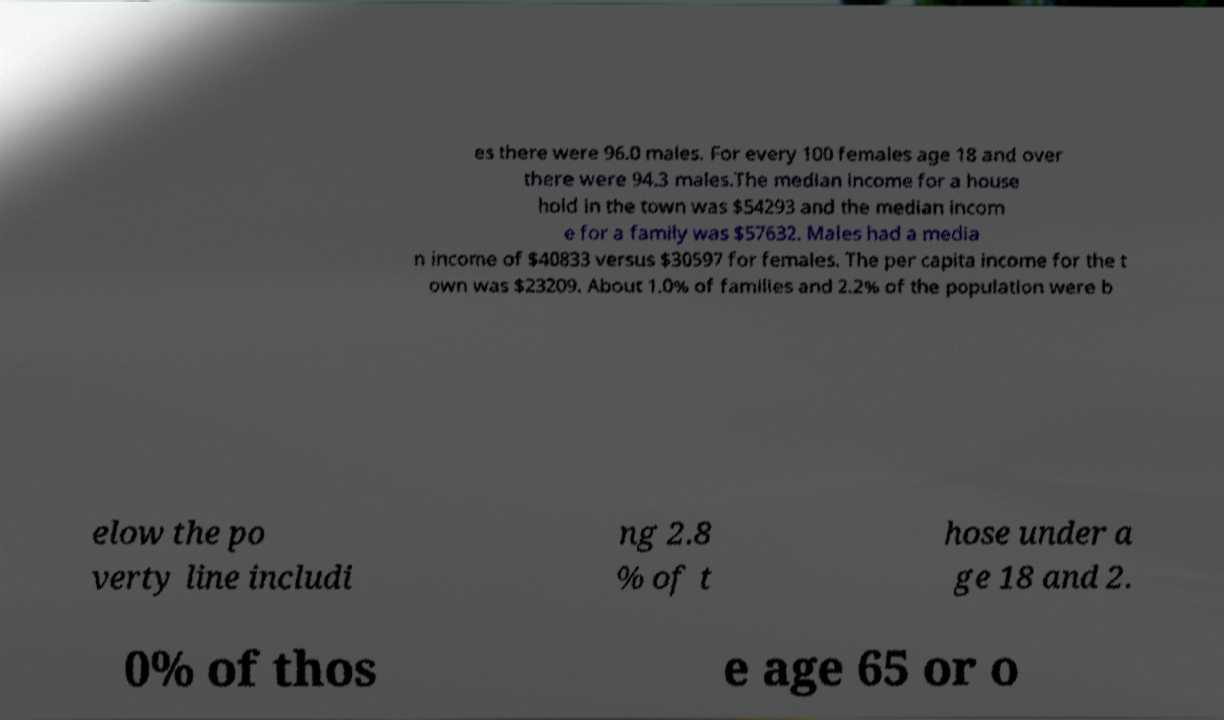Please read and relay the text visible in this image. What does it say? es there were 96.0 males. For every 100 females age 18 and over there were 94.3 males.The median income for a house hold in the town was $54293 and the median incom e for a family was $57632. Males had a media n income of $40833 versus $30597 for females. The per capita income for the t own was $23209. About 1.0% of families and 2.2% of the population were b elow the po verty line includi ng 2.8 % of t hose under a ge 18 and 2. 0% of thos e age 65 or o 